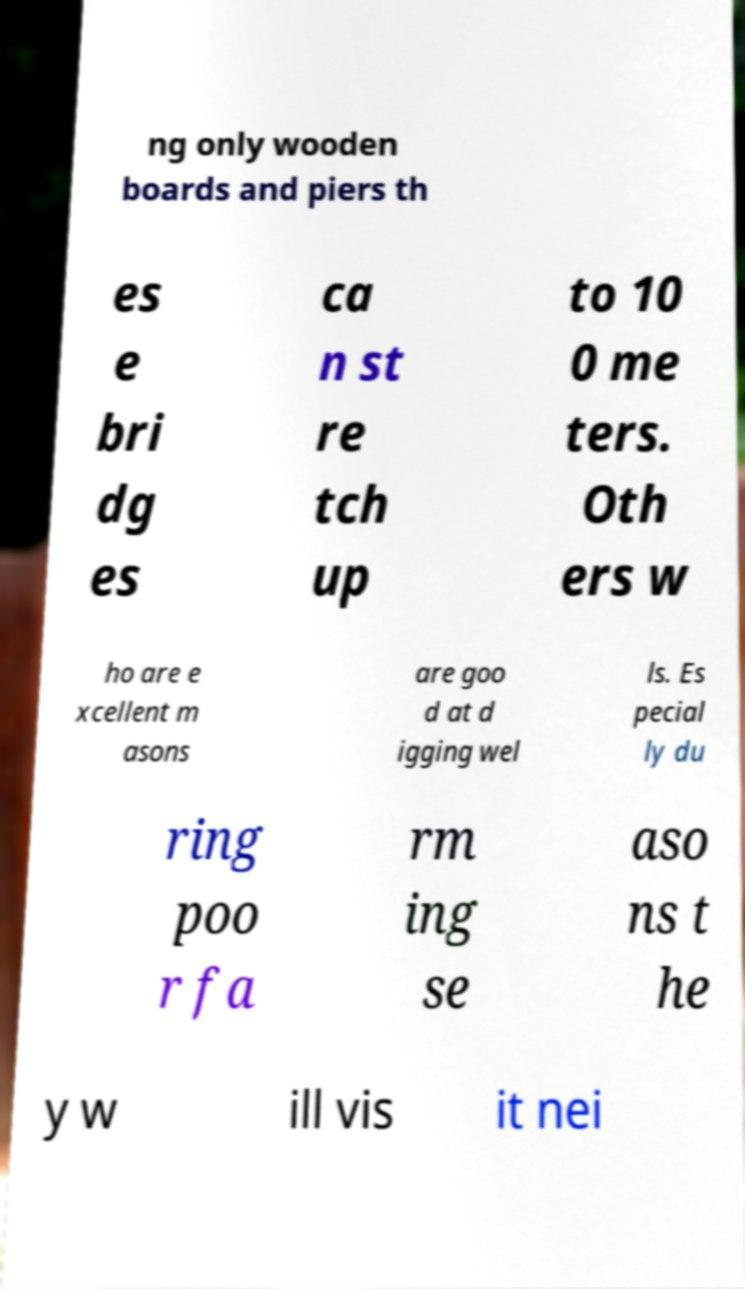Can you accurately transcribe the text from the provided image for me? ng only wooden boards and piers th es e bri dg es ca n st re tch up to 10 0 me ters. Oth ers w ho are e xcellent m asons are goo d at d igging wel ls. Es pecial ly du ring poo r fa rm ing se aso ns t he y w ill vis it nei 